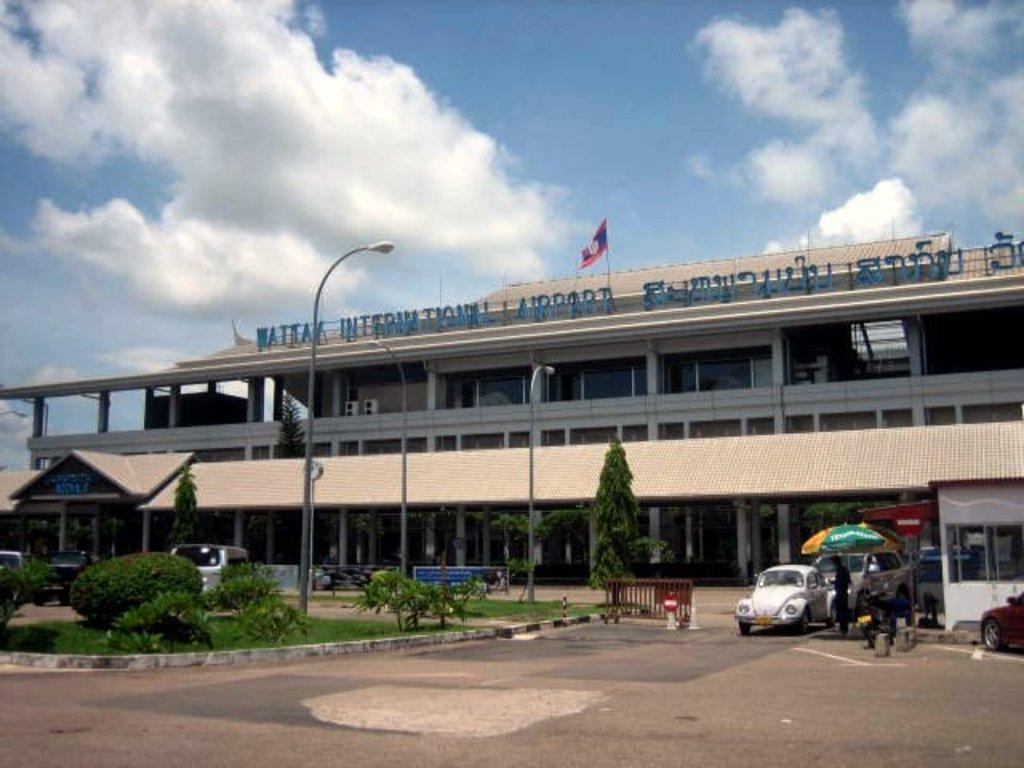What type of structures can be seen in the image? There are buildings in the image. What natural elements are present in the image? There are trees, plants, grass, and clouds in the image. What artificial elements can be seen in the image? There are street lamps, cars, and a flag in the image. Are there any living beings in the image? Yes, there are people in the image. What is visible in the sky in the image? The sky is visible in the image, with clouds present. Can you hear the tin laughing in the image? There is no tin present in the image, and therefore it cannot be heard laughing. 